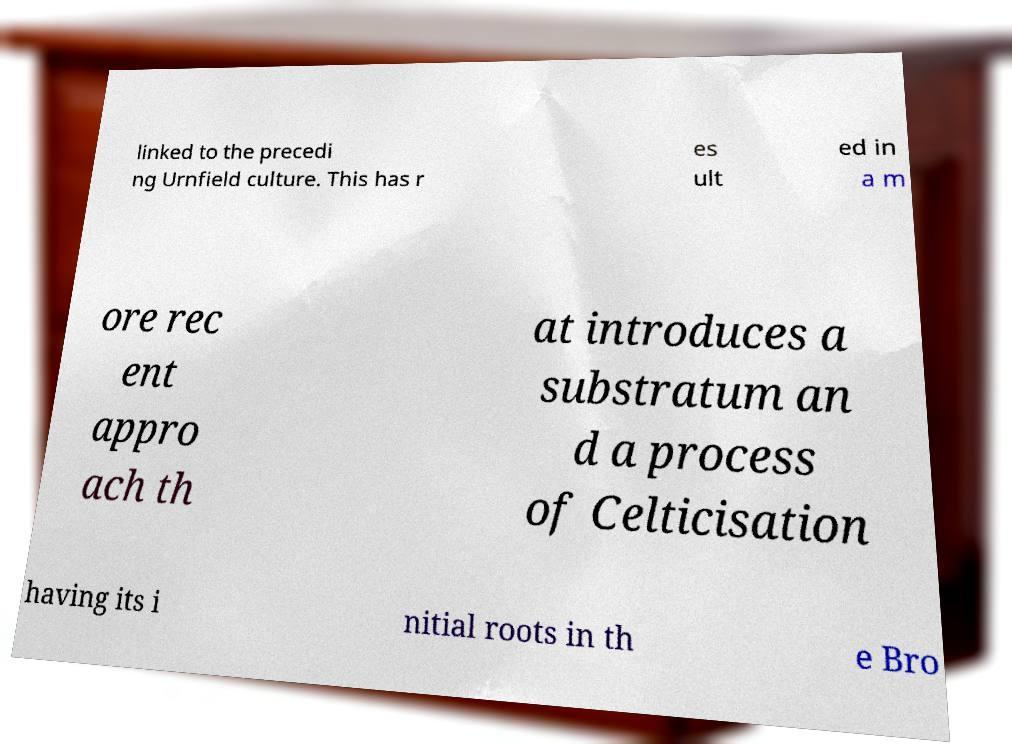Can you accurately transcribe the text from the provided image for me? linked to the precedi ng Urnfield culture. This has r es ult ed in a m ore rec ent appro ach th at introduces a substratum an d a process of Celticisation having its i nitial roots in th e Bro 